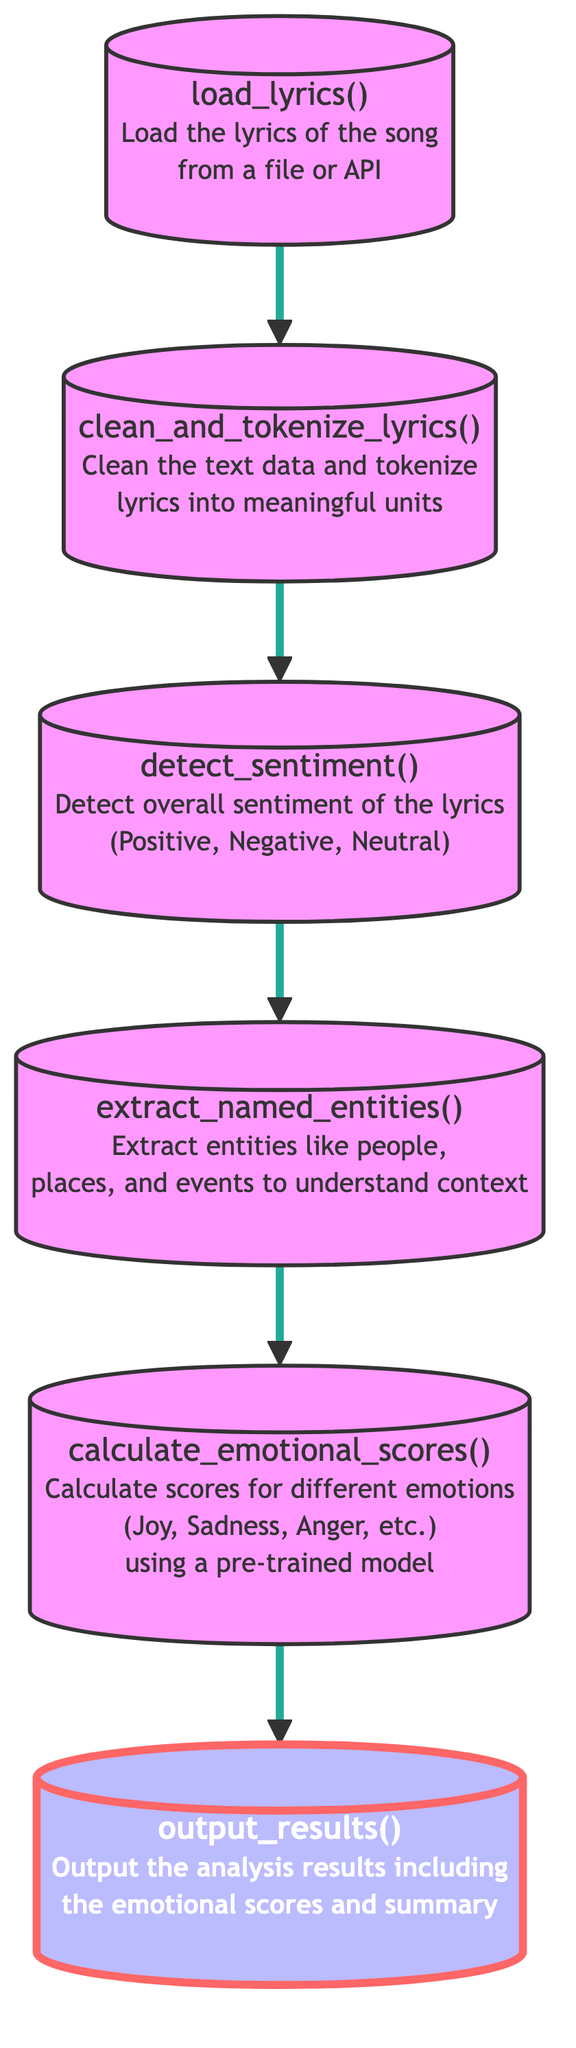What is the first step in the analysis? The first node in the flowchart is "Load lyrics," which indicates that the analysis begins by loading the lyrics of the song from a file or an API.
Answer: Load lyrics How many steps are there in this analysis flow? Counting from the first node to the last, there are a total of six steps in the analysis flow.
Answer: Six steps What is the last step of the function? The last node in the flowchart is "Output results," signifying that the function concludes by presenting the analysis results.
Answer: Output results What function is responsible for cleaning the lyrics? The node "Clean and tokenize lyrics" performs the function of preparing the text data by cleaning and breaking down the lyrics into meaningful elements.
Answer: Clean and tokenize lyrics Which node directly follows "Detect sentiment"? The node that directly follows "Detect sentiment" is "Extract named entities," indicating that after sentiment detection, the next phase involves entity extraction for context understanding.
Answer: Extract named entities What emotion scores are calculated in the analysis? The node "Calculate emotional scores" is designed to compute scores for different emotions such as Joy, Sadness, and Anger using a pre-trained model.
Answer: Joy, Sadness, Anger How is the context of the lyrics understood? The function "Extract named entities" is responsible for understanding the context of the lyrics by extracting relevant entities like people, places, and events.
Answer: Extract named entities What node follows "Extract named entities"? The node that follows "Extract named entities" in the flow sequence is "Calculate emotional scores," indicating that it is the next step after understanding context.
Answer: Calculate emotional scores Which function detects the overall sentiment of the lyrics? The function that detects overall sentiment is represented by the node "Detect sentiment," which categorizes the lyrics as Positive, Negative, or Neutral.
Answer: Detect sentiment 